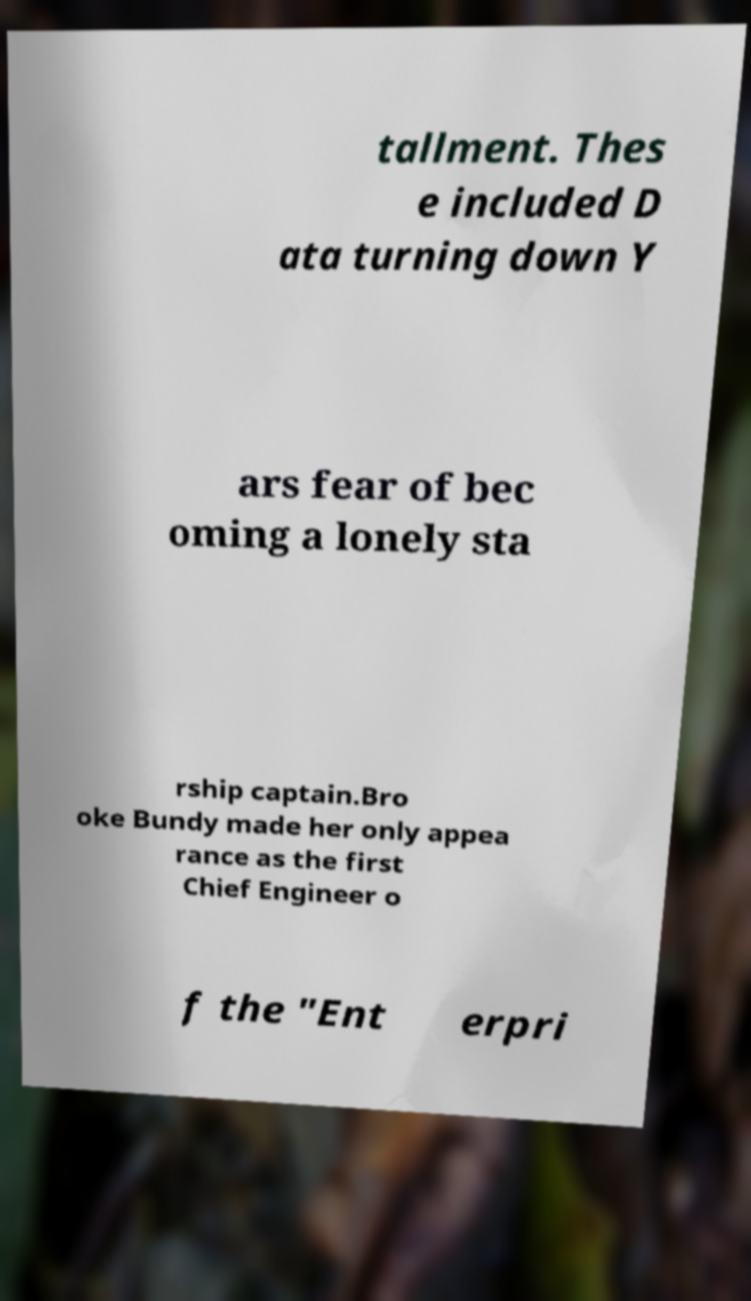Please identify and transcribe the text found in this image. tallment. Thes e included D ata turning down Y ars fear of bec oming a lonely sta rship captain.Bro oke Bundy made her only appea rance as the first Chief Engineer o f the "Ent erpri 